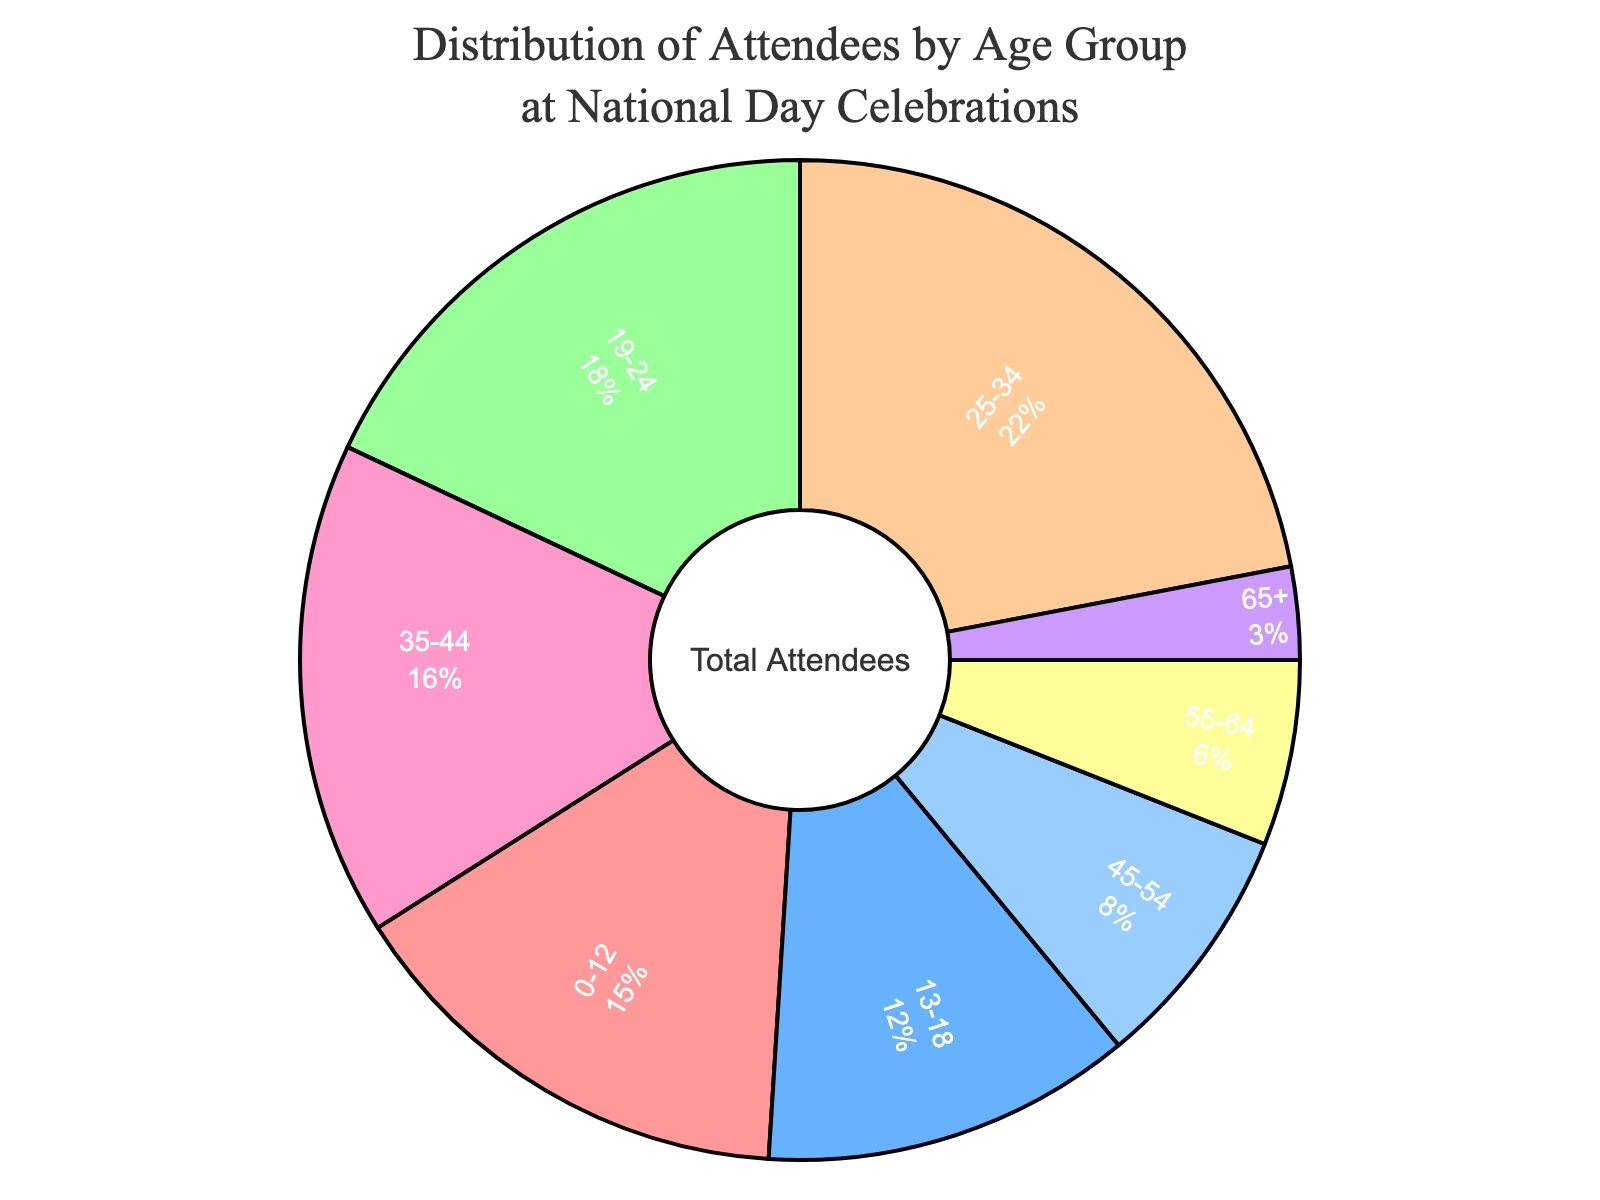What's the largest age group represented in the pie chart? The largest age group is the one with the highest percentage. By looking at the chart, the largest group is the 25-34 age group with 22%.
Answer: 25-34 Which age group has the smallest representation? The smallest group is identified by the smallest percentage. The 65+ age group has only 3%.
Answer: 65+ How much greater is the percentage of the 25-34 age group compared to the 0-12 age group? The percentage of the 25-34 age group is 22%, and the 0-12 age group is 15%. The difference is 22% - 15% = 7%.
Answer: 7% What is the combined percentage of attendees aged 19-24 and 25-34? The percentages for the 19-24 and 25-34 age groups are 18% and 22% respectively. Adding them together gives 18% + 22% = 40%.
Answer: 40% How many percentage points higher is the representation of the 0-12 group compared to the 45-54 group? The percentage for the 0-12 group is 15%, and for the 45-54 group, it is 8%. The difference is 15% - 8% = 7 percentage points.
Answer: 7 Which color represents the 35-44 age group in the pie chart? The color representing the 35-44 age group can be identified visually in the pie chart. The color is light brown.
Answer: light brown What is the total percentage of attendees aged 45 and above? The relevant age groups are 45-54, 55-64, and 65+. Their percentages are 8%, 6%, and 3% respectively. Adding them gives 8% + 6% + 3% = 17%.
Answer: 17% What is the ratio of attendees in the 13-18 age group to the 55-64 age group? The 13-18 age group has 12% and the 55-64 age group has 6%. The ratio is 12% / 6% = 2.
Answer: 2 Which age group corresponds to the second largest segment in the pie chart? The second-largest segment after 25-34 (22%) is for the 19-24 age group with 18%.
Answer: 19-24 How does the percentage of attendees aged 35-44 compare to those aged 13-18? The percentage for 35-44 is 16%, and for 13-18 it is 12%. The 35-44 group is larger.
Answer: 35-44 